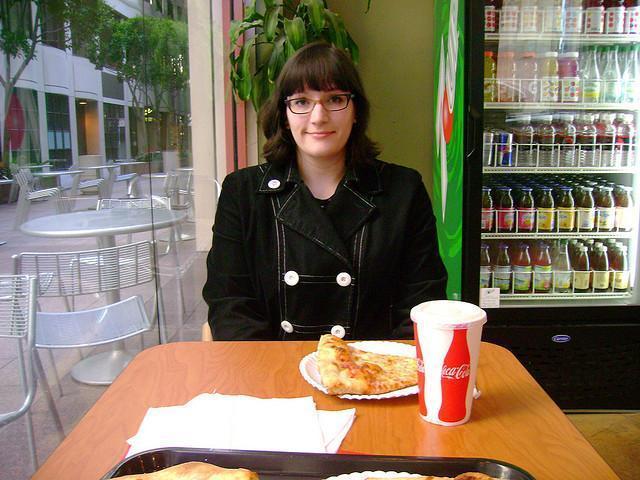How many cups are in the picture?
Give a very brief answer. 1. How many dining tables can be seen?
Give a very brief answer. 1. 